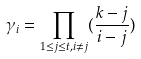<formula> <loc_0><loc_0><loc_500><loc_500>\gamma _ { i } = \prod _ { 1 \leq j \leq t , i \neq j } ( \frac { k - j } { i - j } )</formula> 